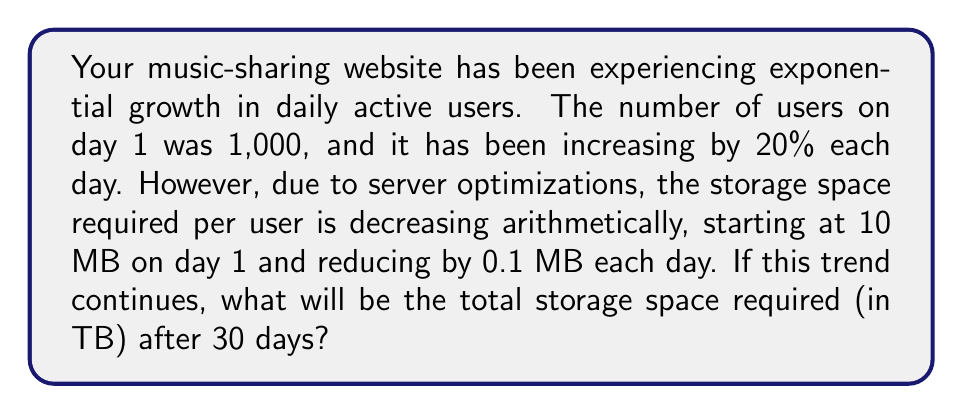Can you solve this math problem? Let's approach this step-by-step:

1) First, let's calculate the number of users for each day:
   $U_n = 1000 \cdot (1.2)^{n-1}$, where $n$ is the day number.

2) The storage space per user for each day:
   $S_n = 10 - 0.1(n-1)$, where $n$ is the day number.

3) The total storage space for day $n$ is $U_n \cdot S_n$.

4) We need to sum this for all 30 days:
   $\sum_{n=1}^{30} U_n \cdot S_n = \sum_{n=1}^{30} 1000 \cdot (1.2)^{n-1} \cdot (10 - 0.1(n-1))$

5) This is an arithmetic-geometric series. The general form is:
   $\sum_{n=1}^{m} ar^{n-1}(b-c(n-1))$

   Where in our case:
   $a = 1000 \cdot 10 = 10000$
   $r = 1.2$
   $b = 10$
   $c = 0.1$
   $m = 30$

6) The sum of this series is given by:
   $S = \frac{a}{1-r}[b(r^m-1) - c((m-1)r^m - mr^{m-1} + 1)]$

7) Plugging in our values:
   $S = \frac{10000}{1-1.2}[10((1.2)^{30}-1) - 0.1((29)(1.2)^{30} - 30(1.2)^{29} + 1)]$

8) Calculating this (you may use a calculator):
   $S \approx 7,481,551,830.7$ MB

9) Converting to TB (1 TB = 1,000,000 MB):
   $7,481,551,830.7 / 1,000,000 \approx 7,481.55$ TB
Answer: 7,481.55 TB 